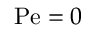<formula> <loc_0><loc_0><loc_500><loc_500>P e = 0</formula> 